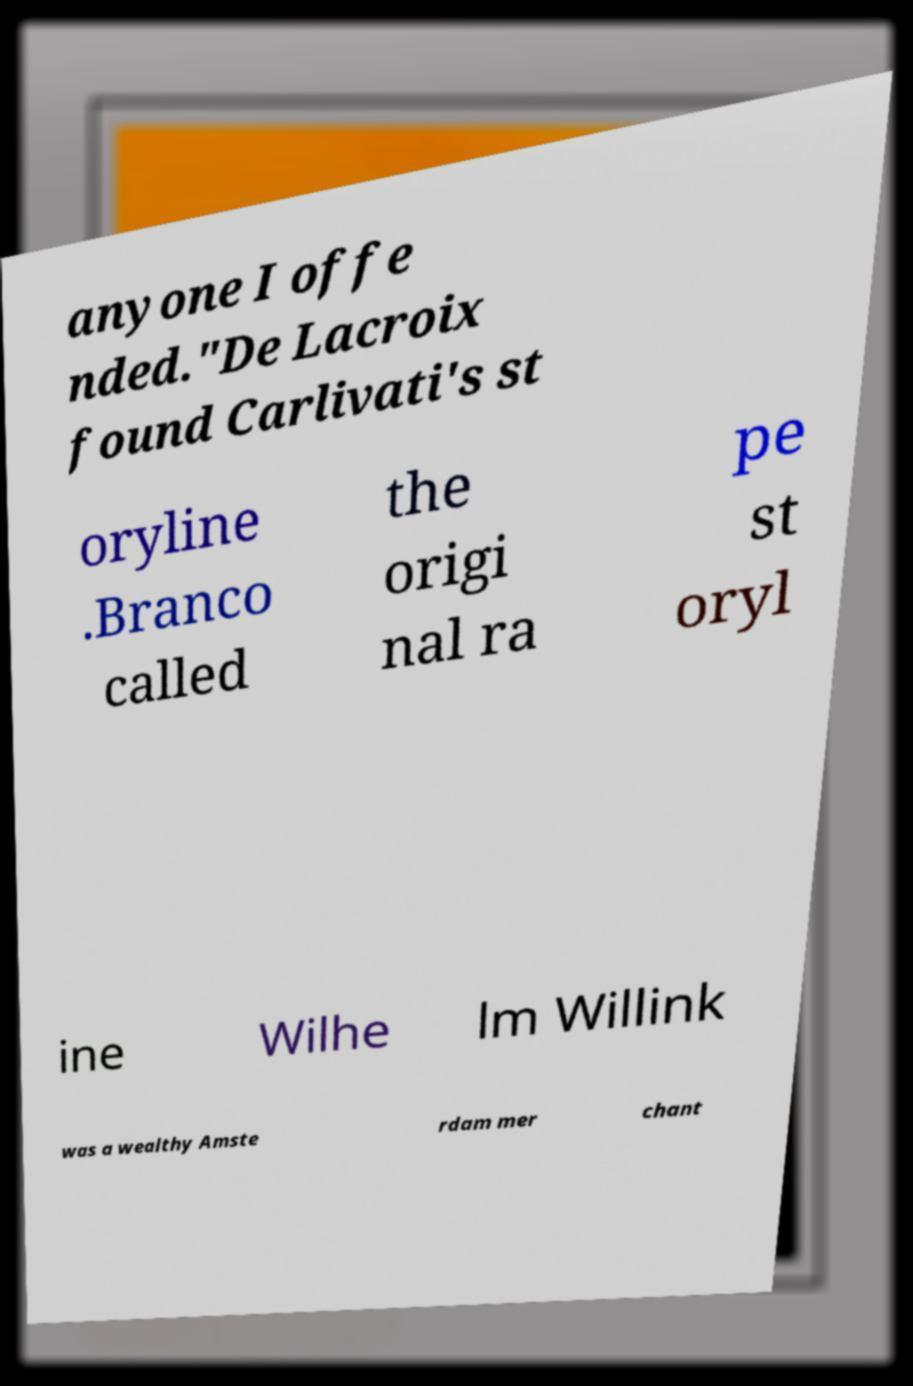Could you extract and type out the text from this image? anyone I offe nded."De Lacroix found Carlivati's st oryline .Branco called the origi nal ra pe st oryl ine Wilhe lm Willink was a wealthy Amste rdam mer chant 